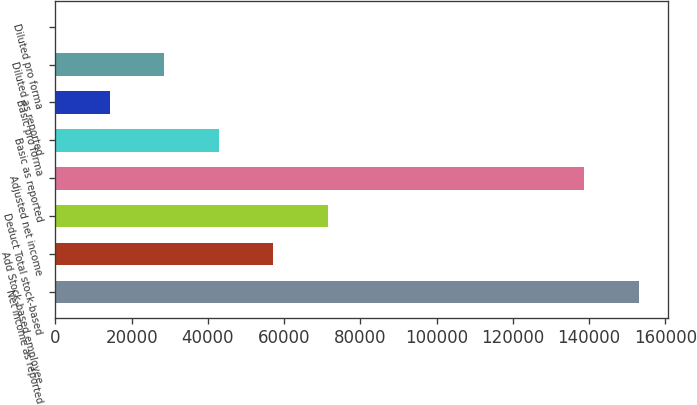<chart> <loc_0><loc_0><loc_500><loc_500><bar_chart><fcel>Net income as reported<fcel>Add Stock-based employee<fcel>Deduct Total stock-based<fcel>Adjusted net income<fcel>Basic as reported<fcel>Basic pro forma<fcel>Diluted as reported<fcel>Diluted pro forma<nl><fcel>153041<fcel>57102.5<fcel>71377.9<fcel>138766<fcel>42827.1<fcel>14276.2<fcel>28551.7<fcel>0.83<nl></chart> 